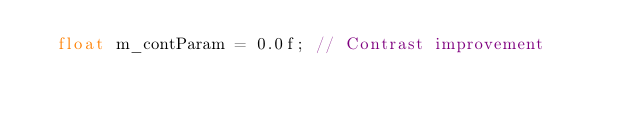<code> <loc_0><loc_0><loc_500><loc_500><_C_>	float m_contParam = 0.0f; // Contrast improvement</code> 